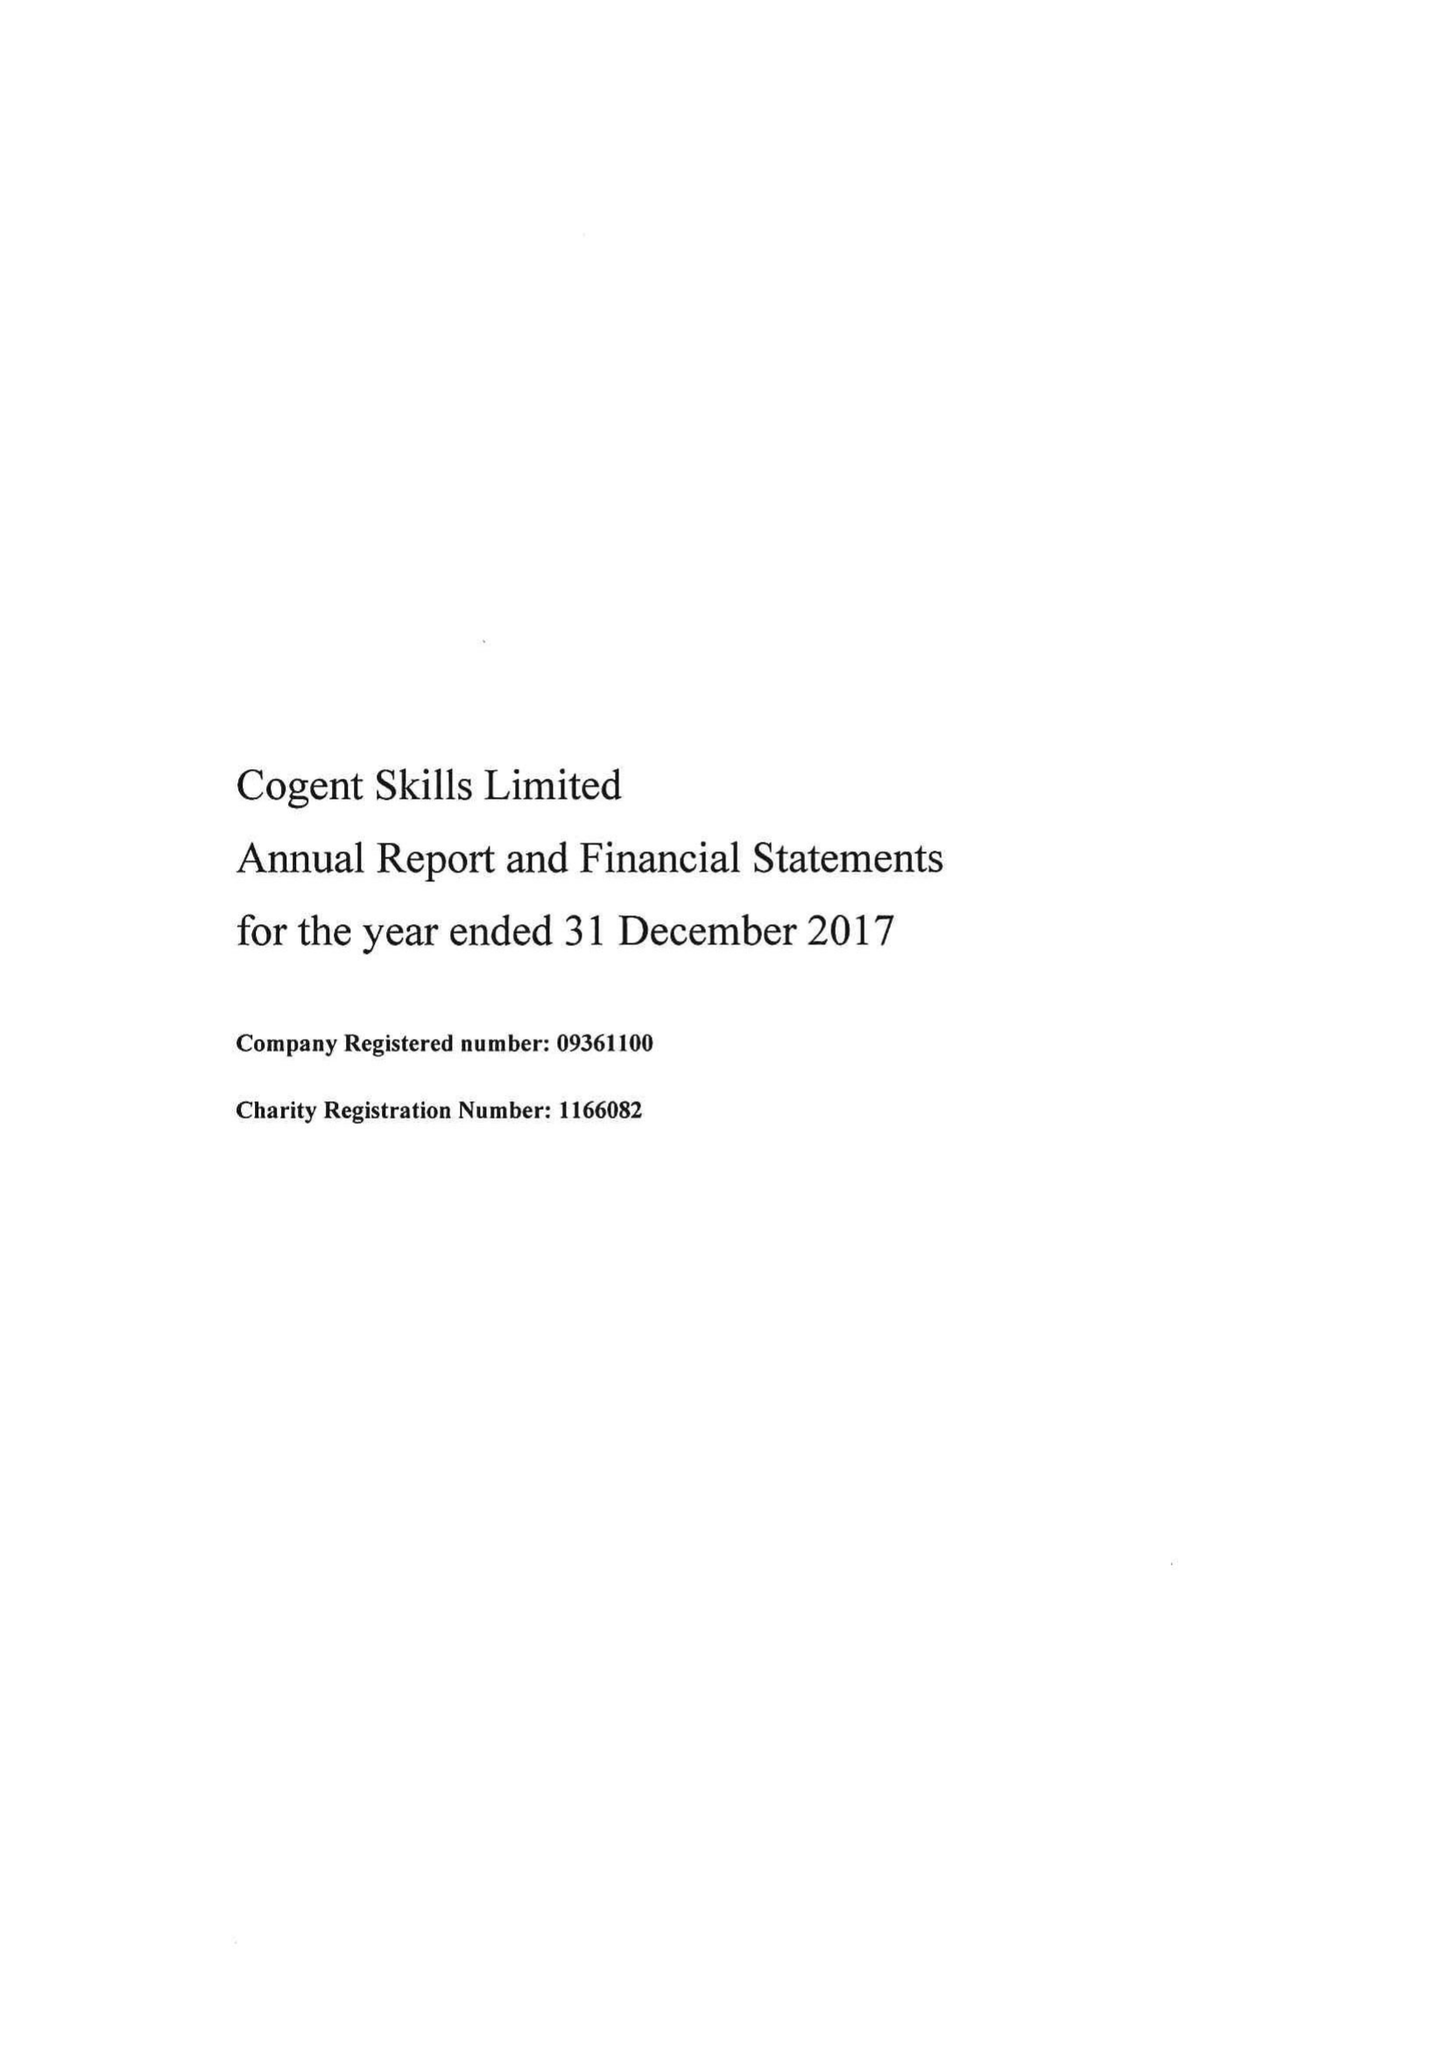What is the value for the address__post_town?
Answer the question using a single word or phrase. WARRINGTON 